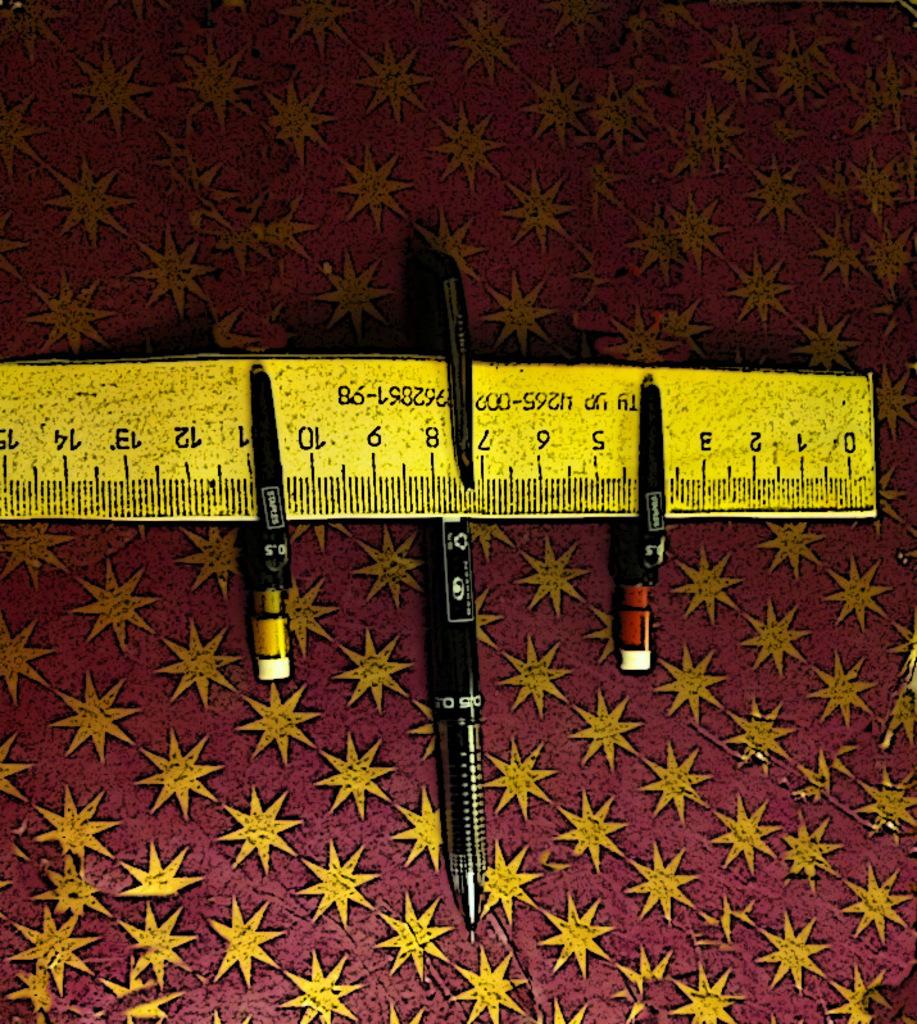What's the largest number this ruler has?
Provide a succinct answer. 15. 